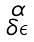Convert formula to latex. <formula><loc_0><loc_0><loc_500><loc_500>\begin{smallmatrix} \alpha \\ \delta \epsilon \end{smallmatrix}</formula> 